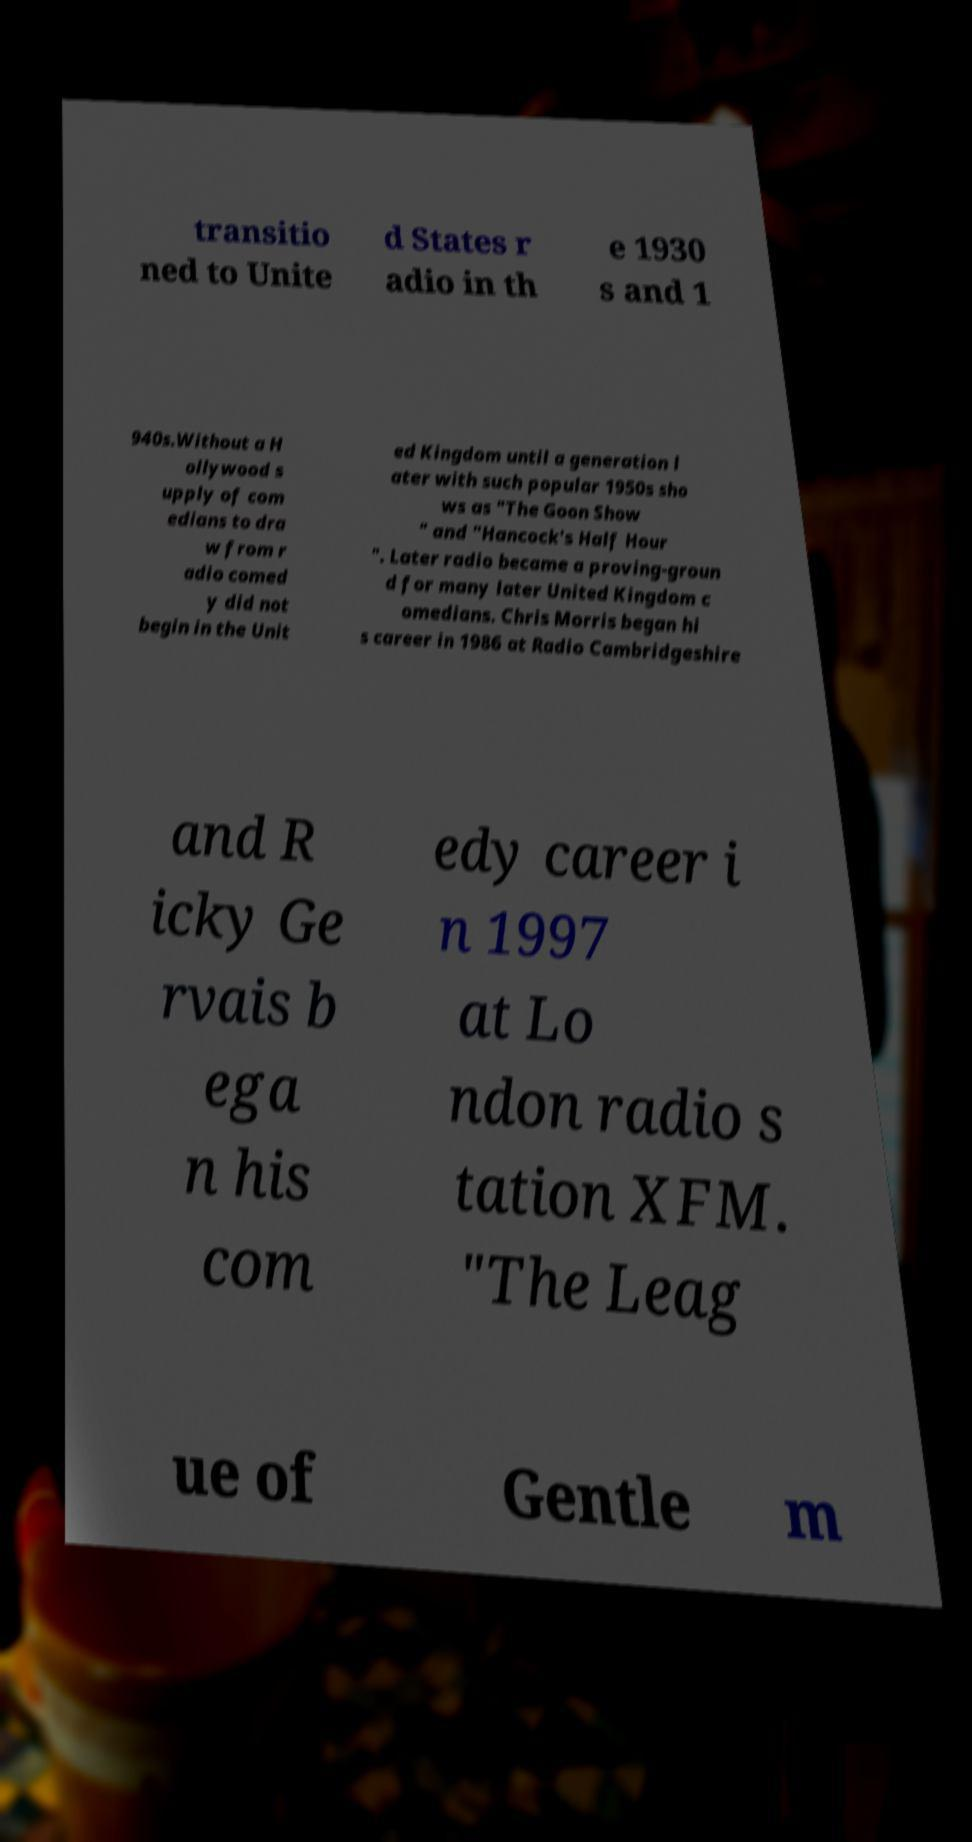What messages or text are displayed in this image? I need them in a readable, typed format. transitio ned to Unite d States r adio in th e 1930 s and 1 940s.Without a H ollywood s upply of com edians to dra w from r adio comed y did not begin in the Unit ed Kingdom until a generation l ater with such popular 1950s sho ws as "The Goon Show " and "Hancock's Half Hour ". Later radio became a proving-groun d for many later United Kingdom c omedians. Chris Morris began hi s career in 1986 at Radio Cambridgeshire and R icky Ge rvais b ega n his com edy career i n 1997 at Lo ndon radio s tation XFM. "The Leag ue of Gentle m 